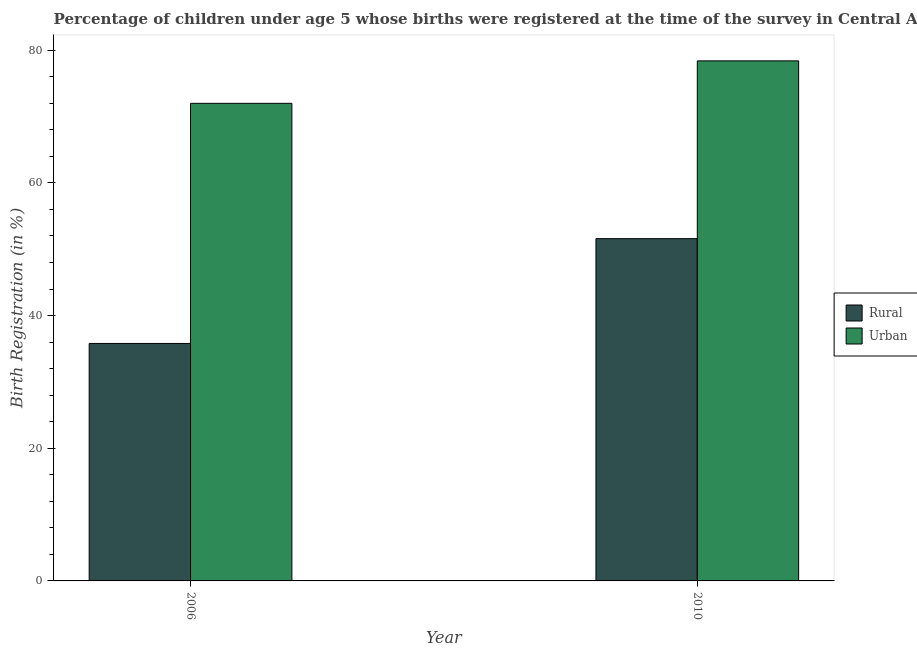How many different coloured bars are there?
Your response must be concise. 2. How many bars are there on the 2nd tick from the right?
Offer a very short reply. 2. What is the label of the 1st group of bars from the left?
Keep it short and to the point. 2006. In how many cases, is the number of bars for a given year not equal to the number of legend labels?
Offer a terse response. 0. Across all years, what is the maximum urban birth registration?
Make the answer very short. 78.4. Across all years, what is the minimum rural birth registration?
Your answer should be very brief. 35.8. What is the total rural birth registration in the graph?
Provide a short and direct response. 87.4. What is the difference between the rural birth registration in 2006 and that in 2010?
Your answer should be compact. -15.8. What is the difference between the urban birth registration in 2006 and the rural birth registration in 2010?
Offer a terse response. -6.4. What is the average rural birth registration per year?
Your response must be concise. 43.7. What is the ratio of the rural birth registration in 2006 to that in 2010?
Offer a terse response. 0.69. What does the 1st bar from the left in 2010 represents?
Give a very brief answer. Rural. What does the 1st bar from the right in 2006 represents?
Your response must be concise. Urban. How many bars are there?
Keep it short and to the point. 4. Are all the bars in the graph horizontal?
Keep it short and to the point. No. How many years are there in the graph?
Your answer should be compact. 2. Does the graph contain any zero values?
Your answer should be very brief. No. Does the graph contain grids?
Ensure brevity in your answer.  No. Where does the legend appear in the graph?
Provide a succinct answer. Center right. How many legend labels are there?
Your answer should be compact. 2. What is the title of the graph?
Keep it short and to the point. Percentage of children under age 5 whose births were registered at the time of the survey in Central African Republic. Does "Number of arrivals" appear as one of the legend labels in the graph?
Offer a very short reply. No. What is the label or title of the Y-axis?
Make the answer very short. Birth Registration (in %). What is the Birth Registration (in %) of Rural in 2006?
Keep it short and to the point. 35.8. What is the Birth Registration (in %) of Rural in 2010?
Your response must be concise. 51.6. What is the Birth Registration (in %) of Urban in 2010?
Your answer should be very brief. 78.4. Across all years, what is the maximum Birth Registration (in %) in Rural?
Give a very brief answer. 51.6. Across all years, what is the maximum Birth Registration (in %) in Urban?
Offer a very short reply. 78.4. Across all years, what is the minimum Birth Registration (in %) of Rural?
Give a very brief answer. 35.8. Across all years, what is the minimum Birth Registration (in %) in Urban?
Your answer should be very brief. 72. What is the total Birth Registration (in %) of Rural in the graph?
Provide a succinct answer. 87.4. What is the total Birth Registration (in %) in Urban in the graph?
Your response must be concise. 150.4. What is the difference between the Birth Registration (in %) in Rural in 2006 and that in 2010?
Give a very brief answer. -15.8. What is the difference between the Birth Registration (in %) of Urban in 2006 and that in 2010?
Ensure brevity in your answer.  -6.4. What is the difference between the Birth Registration (in %) in Rural in 2006 and the Birth Registration (in %) in Urban in 2010?
Ensure brevity in your answer.  -42.6. What is the average Birth Registration (in %) of Rural per year?
Give a very brief answer. 43.7. What is the average Birth Registration (in %) in Urban per year?
Your answer should be very brief. 75.2. In the year 2006, what is the difference between the Birth Registration (in %) of Rural and Birth Registration (in %) of Urban?
Provide a short and direct response. -36.2. In the year 2010, what is the difference between the Birth Registration (in %) of Rural and Birth Registration (in %) of Urban?
Offer a terse response. -26.8. What is the ratio of the Birth Registration (in %) of Rural in 2006 to that in 2010?
Your response must be concise. 0.69. What is the ratio of the Birth Registration (in %) in Urban in 2006 to that in 2010?
Provide a succinct answer. 0.92. 